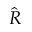<formula> <loc_0><loc_0><loc_500><loc_500>\hat { R }</formula> 